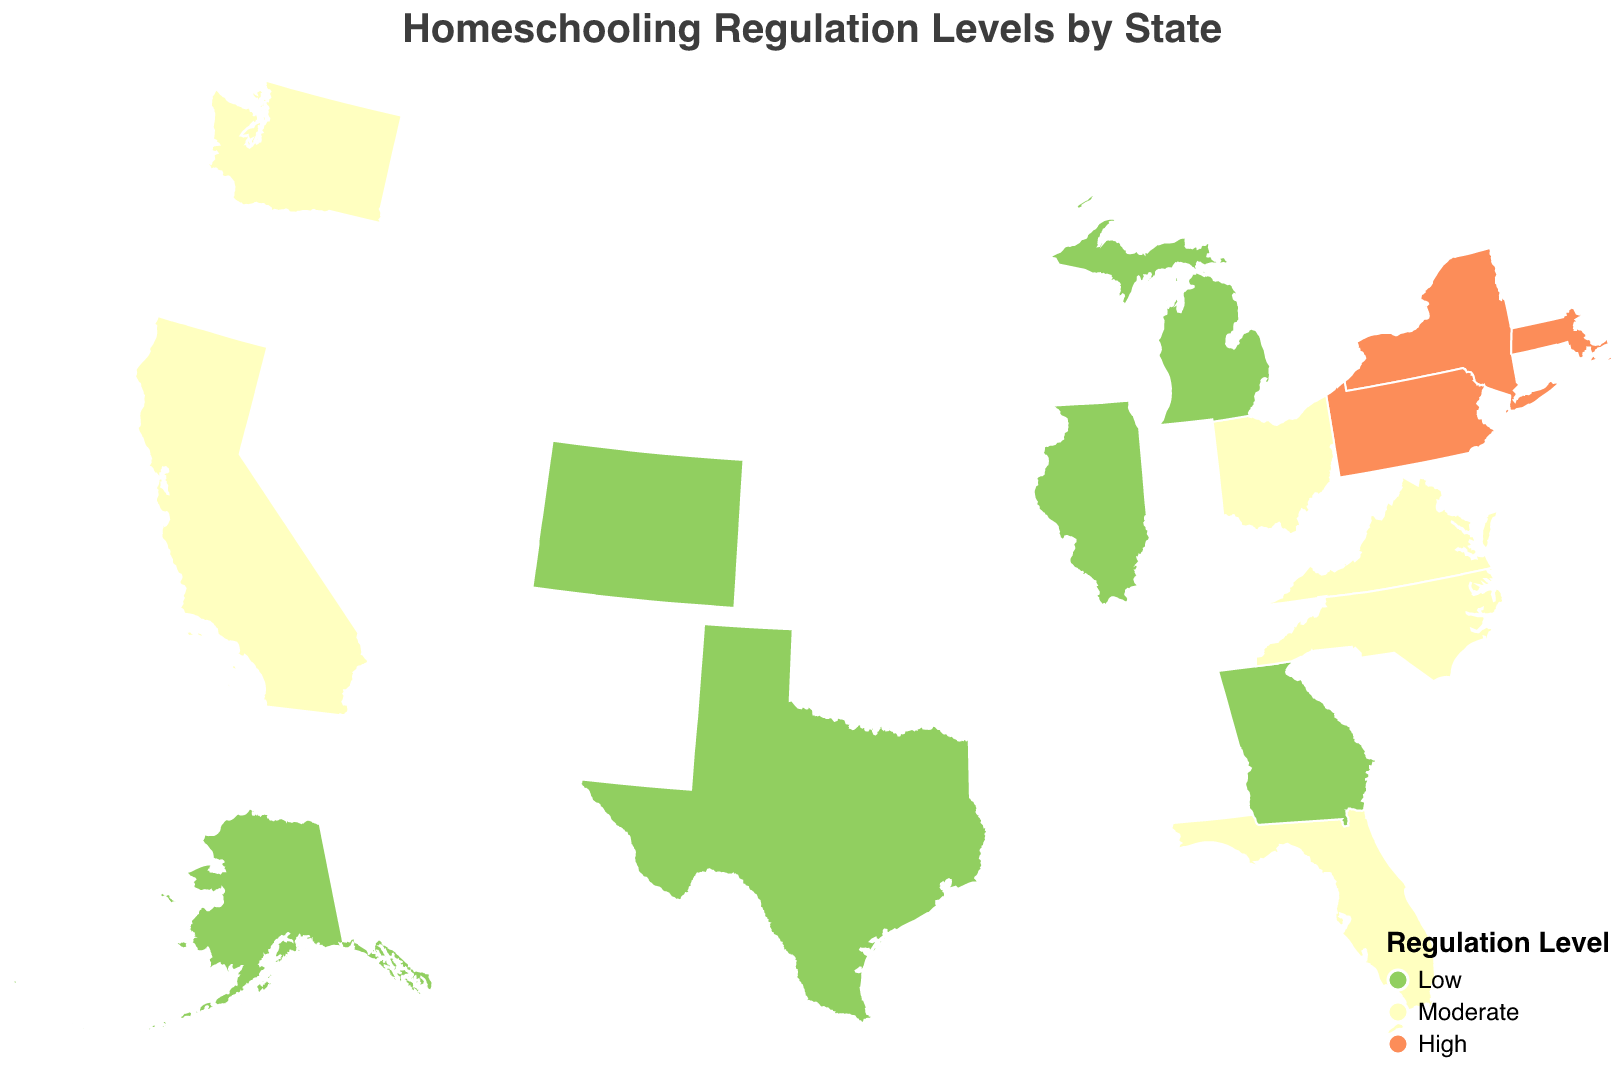What is the title of the figure? The title of the figure is displayed at the top and reads "Homeschooling Regulation Levels by State".
Answer: Homeschooling Regulation Levels by State Which states have high regulation levels for homeschooling? States with high regulation levels are represented by the color indicating "High". From the figure, these states are New York, Pennsylvania, and Massachusetts.
Answer: New York, Pennsylvania, Massachusetts How many states have low regulation levels? States with low regulation levels are represented by a particular color on the map. Counting those states, we see Alaska, Texas, Illinois, Georgia, Colorado, and Michigan. Therefore, six states have low regulation levels.
Answer: 6 What color represents moderate regulation levels on the map? By examining the legend on the bottom-right of the map, moderate regulation levels are represented by the middle color, which is a light yellow.
Answer: Light yellow Which state has the most stringent homeschooling regulations that require a college degree for the teacher? Looking at the tooltip information related to high regulation states, Massachusetts is indicated to require a college degree for teachers, denoting the most stringent regulations.
Answer: Massachusetts Compare the number of states with moderate regulation levels to those with low regulation levels. By counting the states with moderate regulation levels (California, Florida, Ohio, Virginia, Washington, North Carolina) and those with low regulation levels (Alaska, Texas, Illinois, Georgia, Colorado, Michigan), we find there are six states in each category. Hence, the numbers are equal.
Answer: Equal Which state in the southeastern United States has moderate regulation levels? Observing the southeastern region of the geographic plot, Virginia and Florida are southeastern states with moderate regulation levels.
Answer: Virginia, Florida What is the relationship between regulation level and curriculum approval statewide? By referring to data indicators and state color codes, states with high regulation levels (New York, Pennsylvania, Massachusetts) all require curriculum approval, whereas states with low or moderate levels do not have uniform requirements for curriculum approval.
Answer: Only high regulation states require curriculum approval 